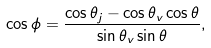<formula> <loc_0><loc_0><loc_500><loc_500>\cos \phi = \frac { \cos \theta _ { j } - \cos \theta _ { v } \cos \theta } { \sin \theta _ { v } \sin \theta } ,</formula> 